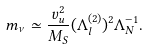Convert formula to latex. <formula><loc_0><loc_0><loc_500><loc_500>m _ { \nu } \simeq \frac { v _ { u } ^ { 2 } } { M _ { S } } ( \Lambda ^ { ( 2 ) } _ { l } ) ^ { 2 } \Lambda _ { N } ^ { - 1 } .</formula> 